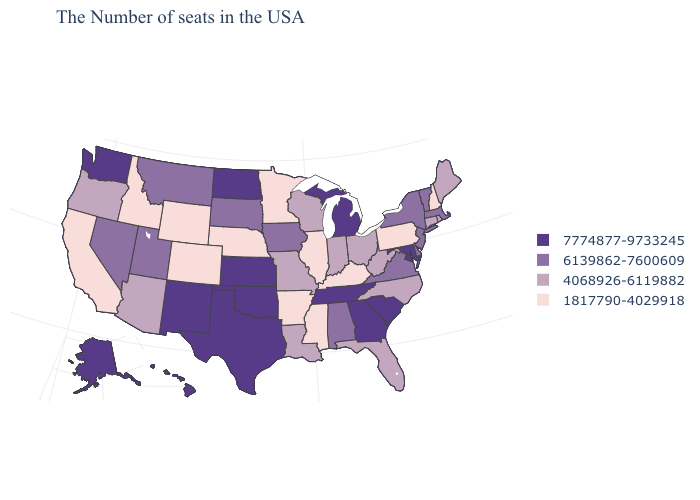Does Alabama have the highest value in the USA?
Be succinct. No. Name the states that have a value in the range 6139862-7600609?
Concise answer only. Massachusetts, Vermont, New York, New Jersey, Delaware, Virginia, Alabama, Iowa, South Dakota, Utah, Montana, Nevada. Name the states that have a value in the range 7774877-9733245?
Write a very short answer. Maryland, South Carolina, Georgia, Michigan, Tennessee, Kansas, Oklahoma, Texas, North Dakota, New Mexico, Washington, Alaska, Hawaii. Does Connecticut have a lower value than Wyoming?
Give a very brief answer. No. What is the highest value in states that border Idaho?
Answer briefly. 7774877-9733245. Name the states that have a value in the range 4068926-6119882?
Be succinct. Maine, Rhode Island, Connecticut, North Carolina, West Virginia, Ohio, Florida, Indiana, Wisconsin, Louisiana, Missouri, Arizona, Oregon. What is the value of Hawaii?
Write a very short answer. 7774877-9733245. What is the value of Wisconsin?
Write a very short answer. 4068926-6119882. What is the lowest value in the USA?
Give a very brief answer. 1817790-4029918. Among the states that border Texas , does Arkansas have the highest value?
Write a very short answer. No. What is the value of Idaho?
Keep it brief. 1817790-4029918. Does the first symbol in the legend represent the smallest category?
Concise answer only. No. What is the lowest value in the West?
Give a very brief answer. 1817790-4029918. Name the states that have a value in the range 6139862-7600609?
Quick response, please. Massachusetts, Vermont, New York, New Jersey, Delaware, Virginia, Alabama, Iowa, South Dakota, Utah, Montana, Nevada. Which states hav the highest value in the South?
Answer briefly. Maryland, South Carolina, Georgia, Tennessee, Oklahoma, Texas. 